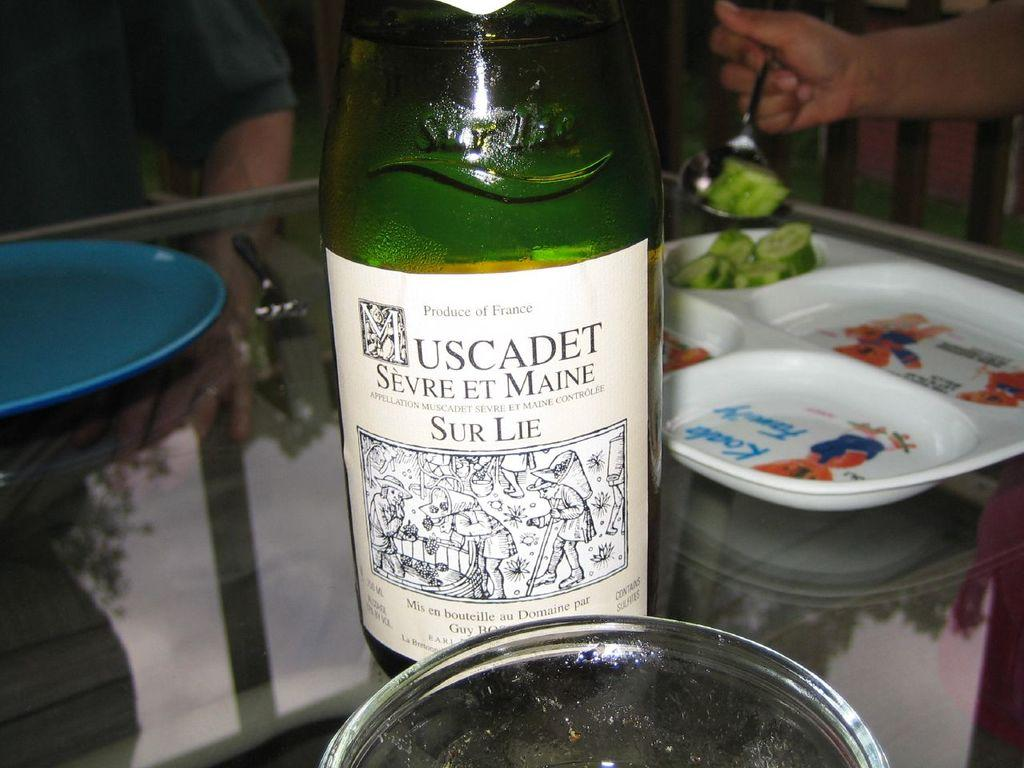Provide a one-sentence caption for the provided image. A bottle of Muscadet Sevre et maine on a table. 